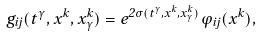<formula> <loc_0><loc_0><loc_500><loc_500>g _ { i j } ( t ^ { \gamma } , x ^ { k } , x ^ { k } _ { \gamma } ) = e ^ { 2 \sigma ( t ^ { \gamma } , x ^ { k } , x ^ { k } _ { \gamma } ) } \varphi _ { i j } ( x ^ { k } ) ,</formula> 